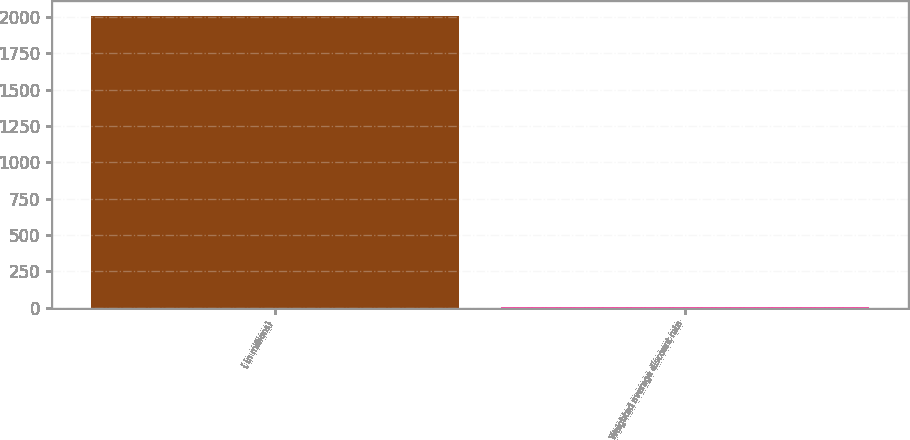Convert chart to OTSL. <chart><loc_0><loc_0><loc_500><loc_500><bar_chart><fcel>( in millions)<fcel>Weighted average discount rate<nl><fcel>2008<fcel>6.75<nl></chart> 